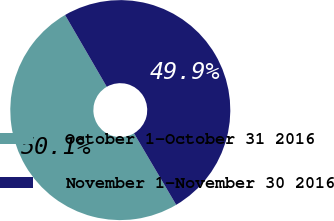Convert chart. <chart><loc_0><loc_0><loc_500><loc_500><pie_chart><fcel>October 1-October 31 2016<fcel>November 1-November 30 2016<nl><fcel>50.11%<fcel>49.89%<nl></chart> 